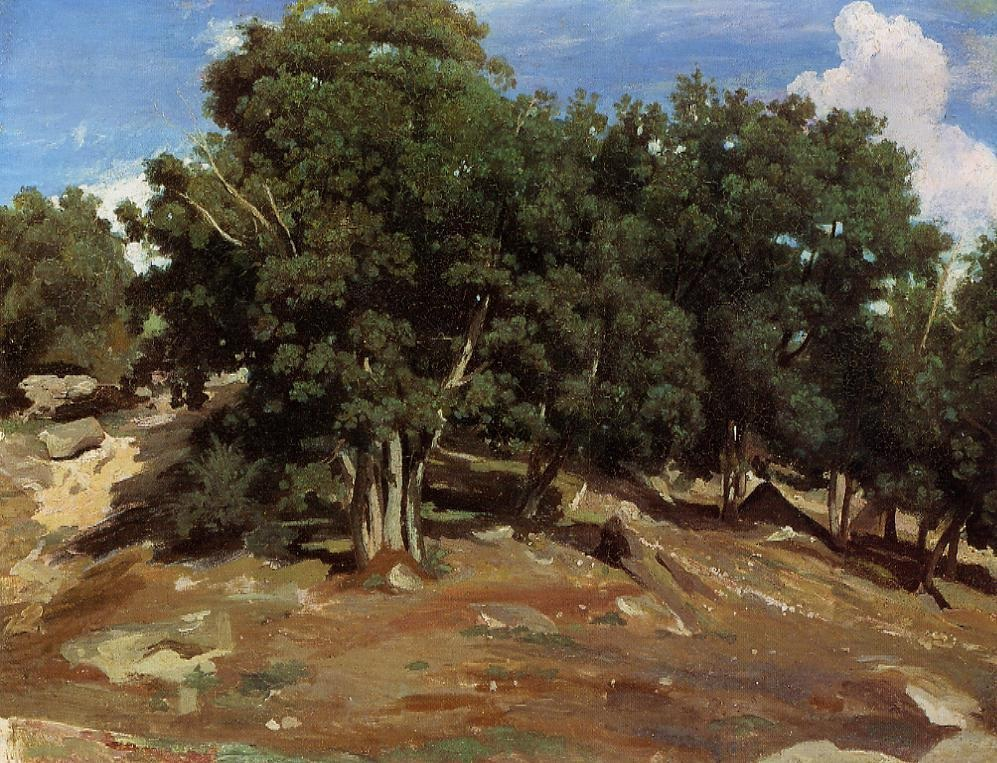What historical period do you think this painting belongs to, and why? This painting appears to belong to the Impressionist period, which flourished in the late 19th century. The loose brushstrokes and the focus on the interplay of color and light are characteristic of impressionist techniques. Additionally, the painting's emphasis on capturing the mood and atmosphere of the scene, rather than detailed realism, aligns with the goals and aesthetics of Impressionist artists who sought to depict the transient effects of light and nature.  Imagine this landscape is part of a hidden, ancient civilization. What remnants might you find? In imagining this landscape as part of a hidden, ancient civilization, one might find remnants of beautifully carved stone pillars peeking through the undergrowth, partially covered in moss. Vines and flowers would weave around these structures, hinting at the passage of time. Scattered throughout the hillside could be ancient artifacts such as pottery shards, tools, and fragments of murals depicting scenes of daily life and mythological tales. Hidden among the trees, a forgotten temple could sit, with intricate carvings and statues standing guard, alluding to the sophisticated artistry and beliefs of the civilization that once thrived in harmony with nature. 